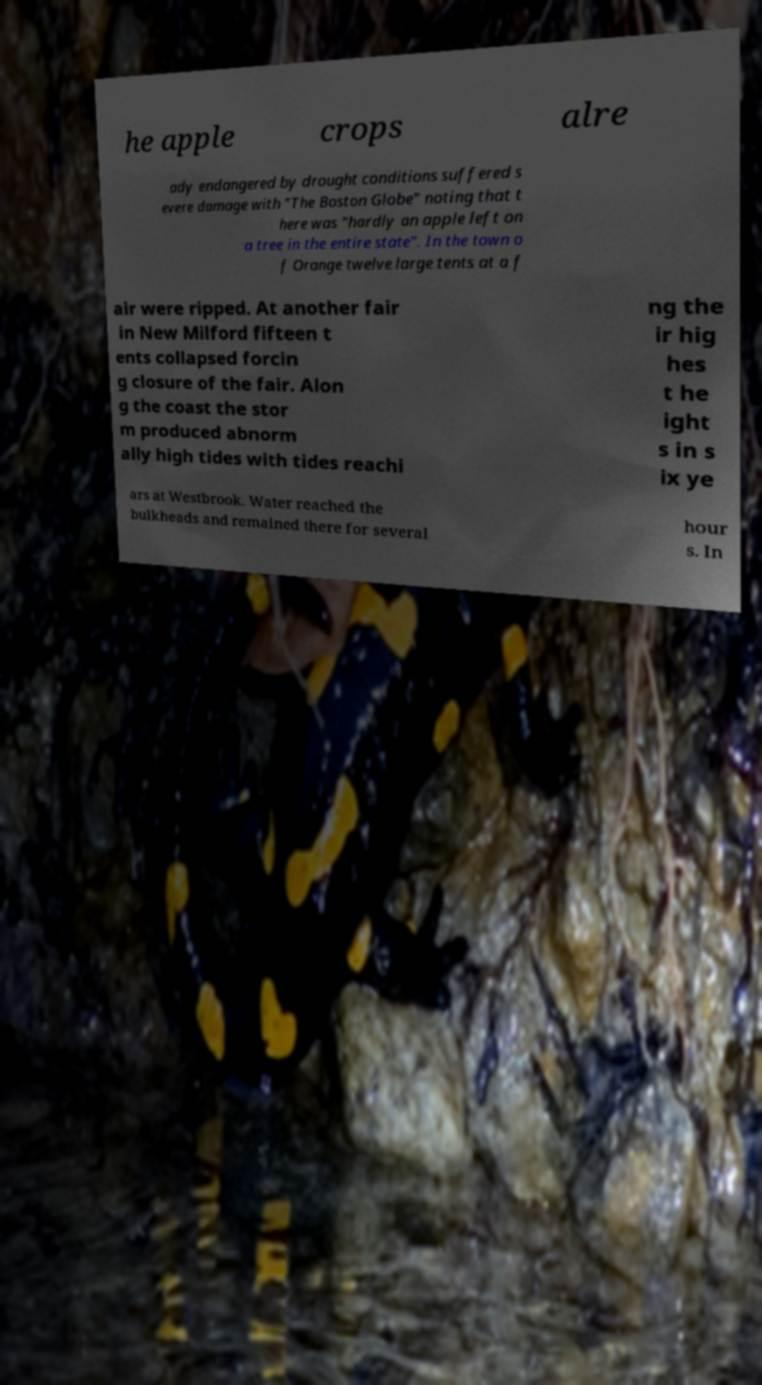What messages or text are displayed in this image? I need them in a readable, typed format. he apple crops alre ady endangered by drought conditions suffered s evere damage with "The Boston Globe" noting that t here was "hardly an apple left on a tree in the entire state". In the town o f Orange twelve large tents at a f air were ripped. At another fair in New Milford fifteen t ents collapsed forcin g closure of the fair. Alon g the coast the stor m produced abnorm ally high tides with tides reachi ng the ir hig hes t he ight s in s ix ye ars at Westbrook. Water reached the bulkheads and remained there for several hour s. In 